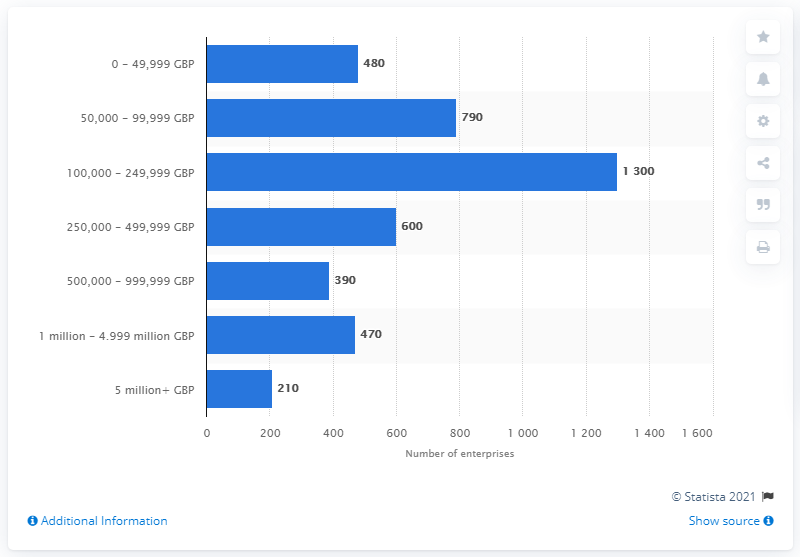Draw attention to some important aspects in this diagram. As of March 2020, it was reported that 210 enterprises in the textile manufacturing sector had a turnover of more than 5 million GBP. 